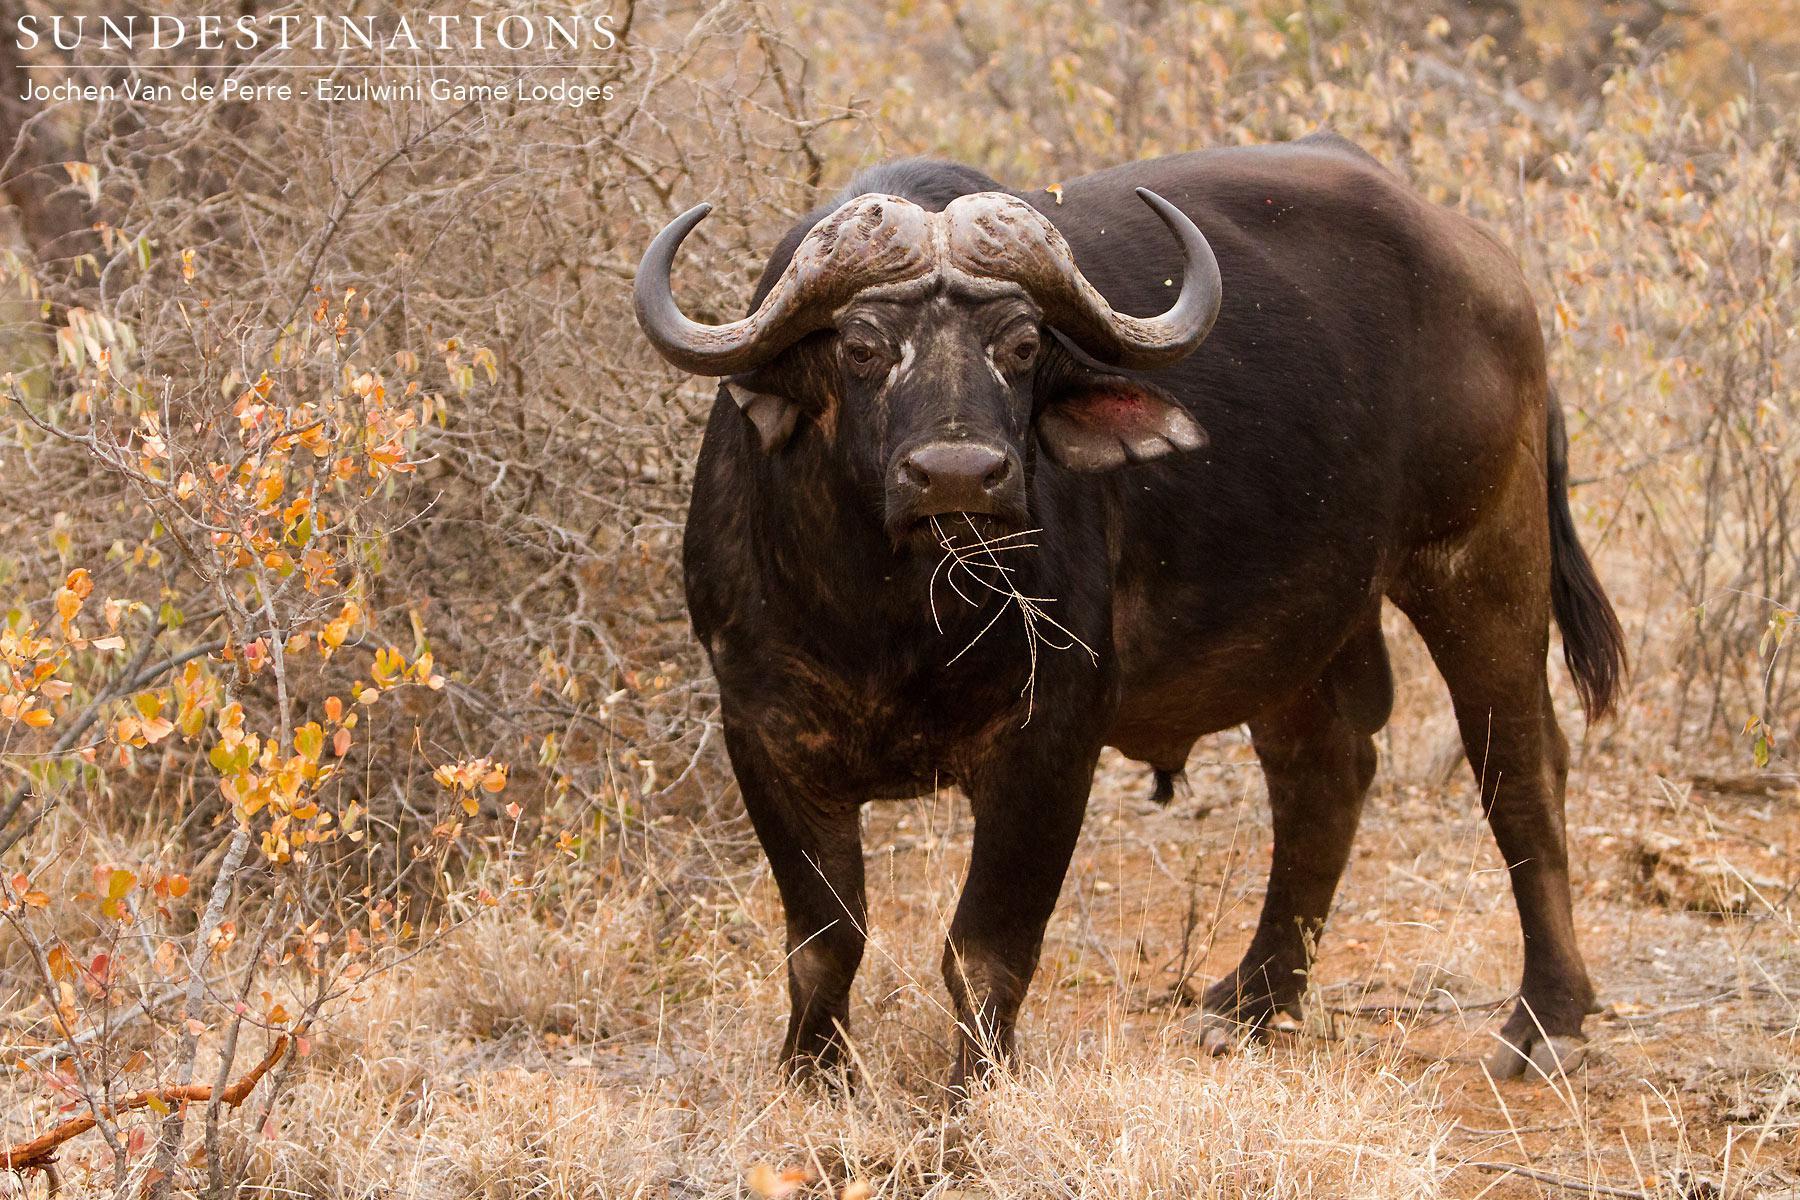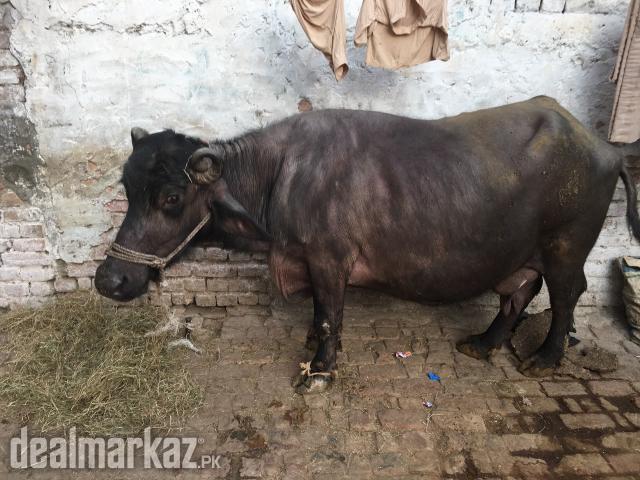The first image is the image on the left, the second image is the image on the right. For the images displayed, is the sentence "In the image to the left, the ox is standing, surrounded by GREEN vegetation/grass." factually correct? Answer yes or no. No. 